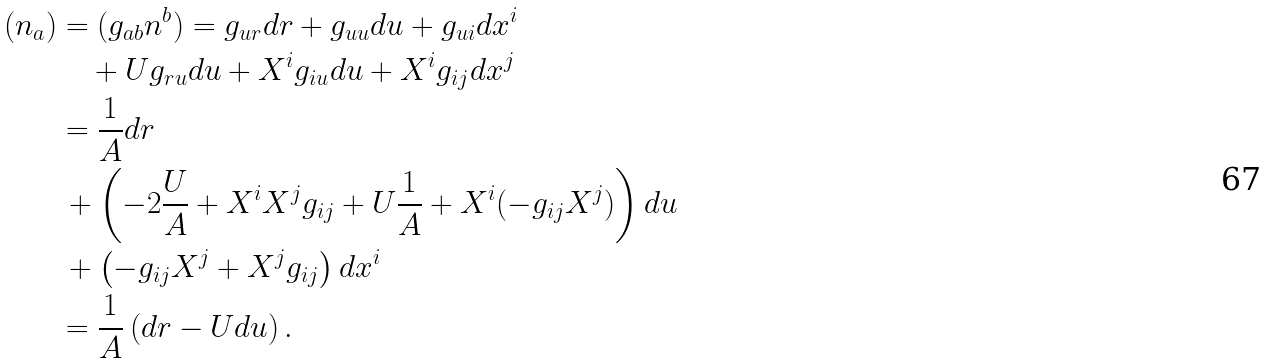Convert formula to latex. <formula><loc_0><loc_0><loc_500><loc_500>( n _ { a } ) & = ( g _ { a b } n ^ { b } ) = g _ { u r } d r + g _ { u u } d u + g _ { u i } d x ^ { i } \\ & \quad + U g _ { r u } d u + X ^ { i } g _ { i u } d u + X ^ { i } g _ { i j } d x ^ { j } \\ & = \frac { 1 } { A } d r \\ & \, + \left ( - 2 \frac { U } { A } + X ^ { i } X ^ { j } g _ { i j } + U \frac { 1 } { A } + X ^ { i } ( - g _ { i j } X ^ { j } ) \right ) d u \\ & \, + \left ( - g _ { i j } X ^ { j } + X ^ { j } g _ { i j } \right ) d x ^ { i } \\ & = \frac { 1 } { A } \left ( d r - U d u \right ) .</formula> 